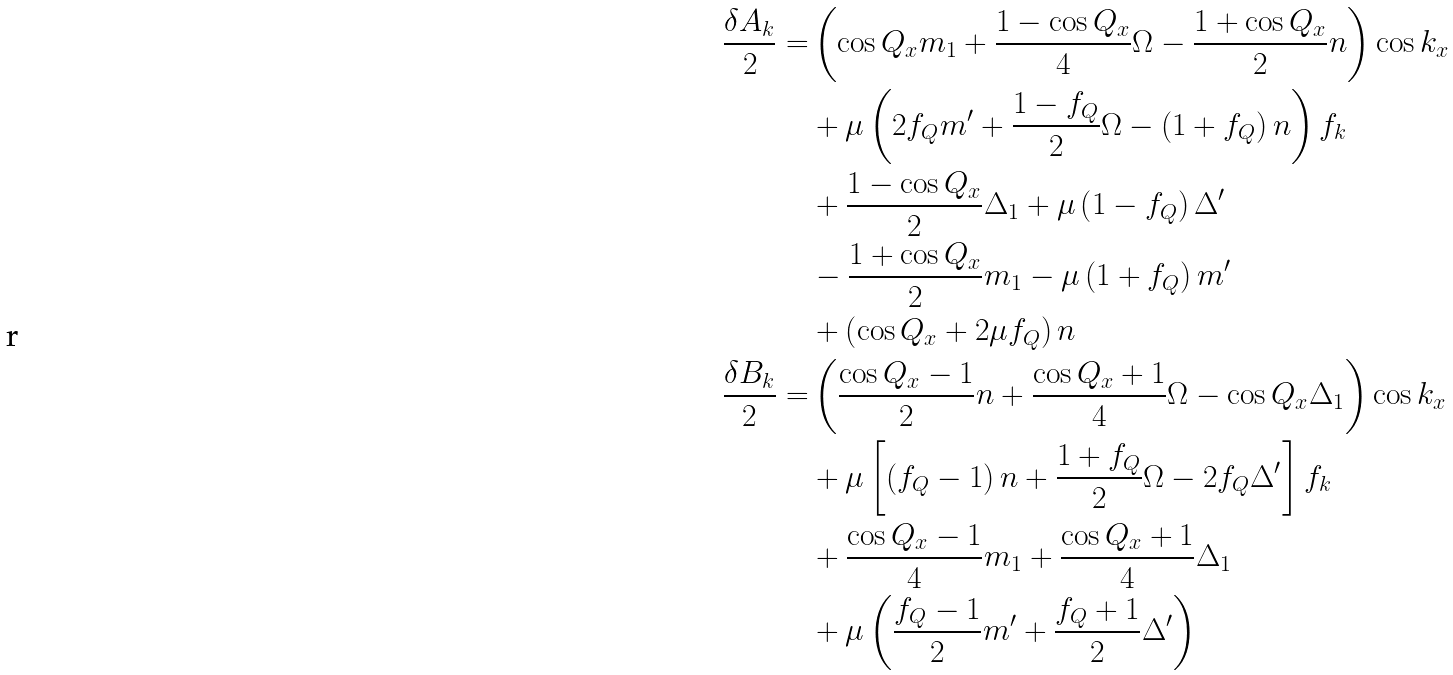<formula> <loc_0><loc_0><loc_500><loc_500>\frac { \delta A _ { k } } { 2 } = & \left ( \cos { Q _ { x } } m _ { 1 } + \frac { 1 - \cos { Q _ { x } } } { 4 } \Omega - \frac { 1 + \cos { Q _ { x } } } { 2 } n \right ) \cos { k _ { x } } \\ & + \mu \left ( 2 f _ { Q } m ^ { \prime } + \frac { 1 - f _ { Q } } { 2 } \Omega - \left ( 1 + f _ { Q } \right ) n \right ) f _ { k } \\ & + \frac { 1 - \cos { Q _ { x } } } { 2 } \Delta _ { 1 } + \mu \left ( 1 - f _ { Q } \right ) \Delta ^ { \prime } \\ & - \frac { 1 + \cos { Q _ { x } } } { 2 } m _ { 1 } - \mu \left ( 1 + f _ { Q } \right ) m ^ { \prime } \\ & + \left ( \cos { Q _ { x } } + 2 \mu f _ { Q } \right ) n \\ \frac { \delta B _ { k } } { 2 } = & \left ( \frac { \cos { Q _ { x } } - 1 } { 2 } n + \frac { \cos { Q _ { x } } + 1 } { 4 } \Omega - \cos { Q _ { x } } \Delta _ { 1 } \right ) \cos { k _ { x } } \\ & + \mu \left [ \left ( f _ { Q } - 1 \right ) n + \frac { 1 + f _ { Q } } { 2 } \Omega - 2 f _ { Q } \Delta ^ { \prime } \right ] f _ { k } \\ & + \frac { \cos { Q _ { x } } - 1 } { 4 } m _ { 1 } + \frac { \cos { Q _ { x } } + 1 } { 4 } \Delta _ { 1 } \\ & + \mu \left ( \frac { f _ { Q } - 1 } { 2 } m ^ { \prime } + \frac { f _ { Q } + 1 } { 2 } \Delta ^ { \prime } \right )</formula> 